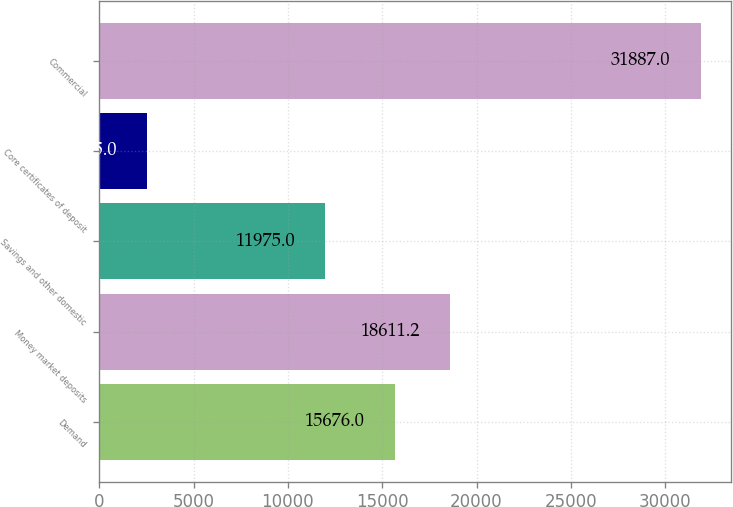Convert chart. <chart><loc_0><loc_0><loc_500><loc_500><bar_chart><fcel>Demand<fcel>Money market deposits<fcel>Savings and other domestic<fcel>Core certificates of deposit<fcel>Commercial<nl><fcel>15676<fcel>18611.2<fcel>11975<fcel>2535<fcel>31887<nl></chart> 